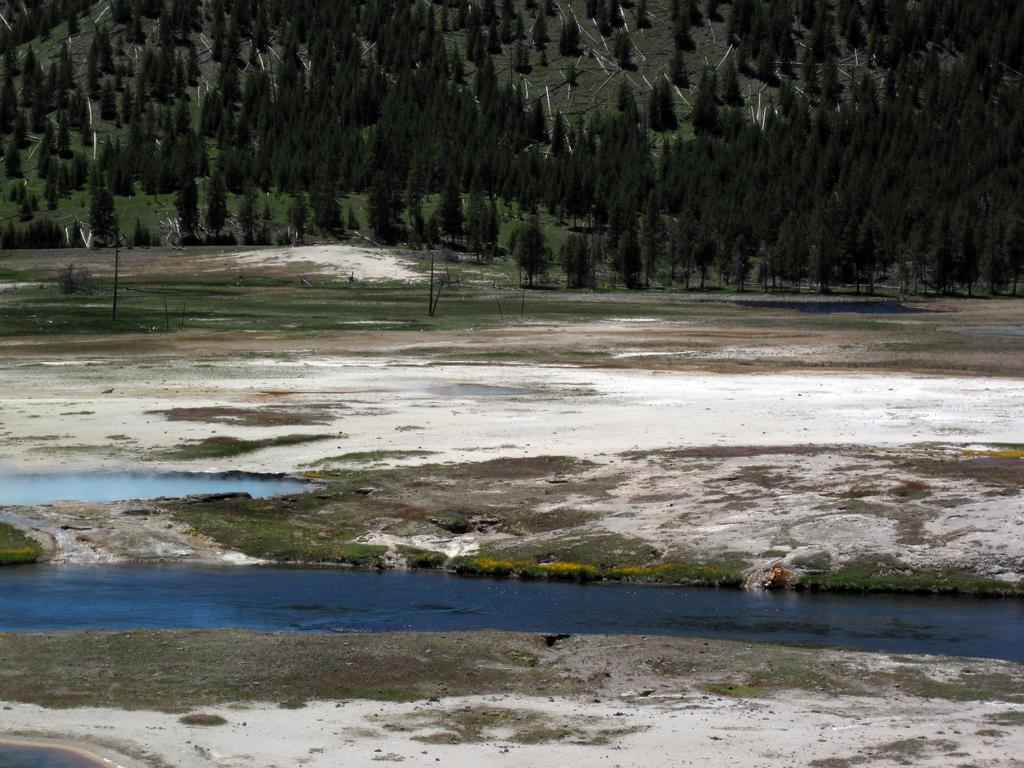What type of natural environment is visible in the background of the image? There are trees in the background of the image. What is located in the center of the image? There is water in the center of the image. What type of terrain is at the bottom of the image? There is sand at the bottom of the image. Can you see the person's face in the image? There is no person or face present in the image; it features trees, water, and sand. How many toes are visible in the image? There are no toes visible in the image. 